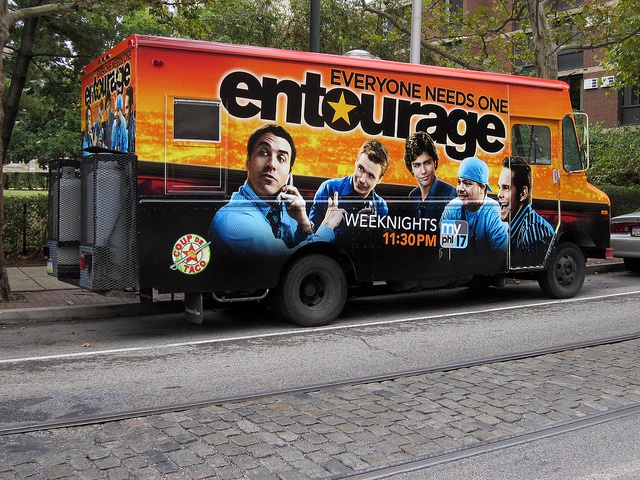Describe the objects in this image and their specific colors. I can see truck in gray, black, red, and orange tones, people in gray, black, lightblue, lightgray, and blue tones, people in gray, black, navy, and maroon tones, people in gray, black, tan, navy, and maroon tones, and people in gray, black, blue, lightblue, and lightgray tones in this image. 